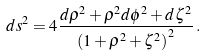Convert formula to latex. <formula><loc_0><loc_0><loc_500><loc_500>d s ^ { 2 } = 4 \frac { d \rho ^ { 2 } + \rho ^ { 2 } d \phi ^ { 2 } + d \zeta ^ { 2 } } { \left ( 1 + \rho ^ { 2 } + \zeta ^ { 2 } \right ) ^ { 2 } } \, .</formula> 